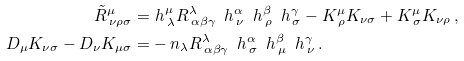<formula> <loc_0><loc_0><loc_500><loc_500>\tilde { R } ^ { \mu } _ { \, \nu \rho \sigma } = & \ h ^ { \mu } _ { \, \lambda } R ^ { \lambda } _ { \, \alpha \beta \gamma } \, \ h ^ { \alpha } _ { \, \nu } \, \ h ^ { \beta } _ { \, \rho } \, \ h ^ { \gamma } _ { \, \sigma } - K ^ { \mu } _ { \, \rho } K _ { \nu \sigma } + K ^ { \mu } _ { \, \sigma } K _ { \nu \rho } \, , \\ D _ { \mu } K _ { \nu \sigma } - D _ { \nu } K _ { \mu \sigma } = & - n _ { \lambda } R ^ { \lambda } _ { \, \alpha \beta \gamma } \, \ h ^ { \alpha } _ { \, \sigma } \, \ h ^ { \beta } _ { \, \mu } \, \ h ^ { \gamma } _ { \, \nu } \, .</formula> 